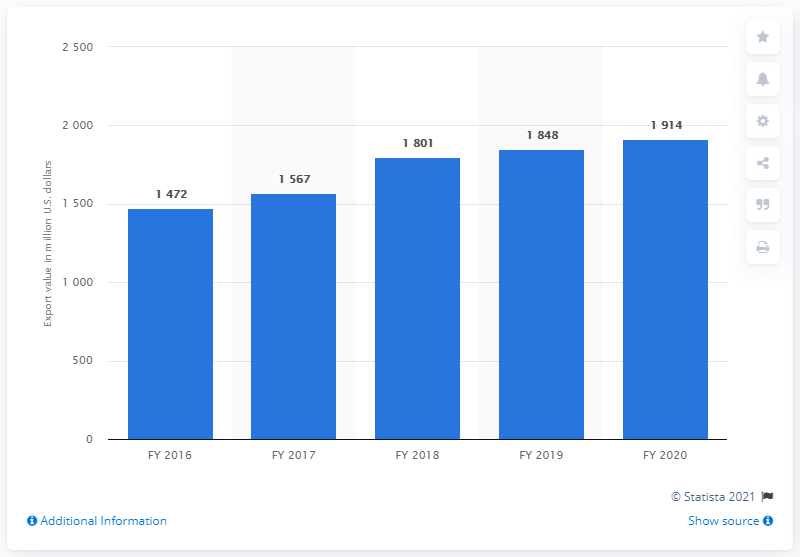Outline some significant characteristics in this image. According to the data for the financial year of 2020, the export value of cosmetics, soap, and toiletries from India was 1914. 